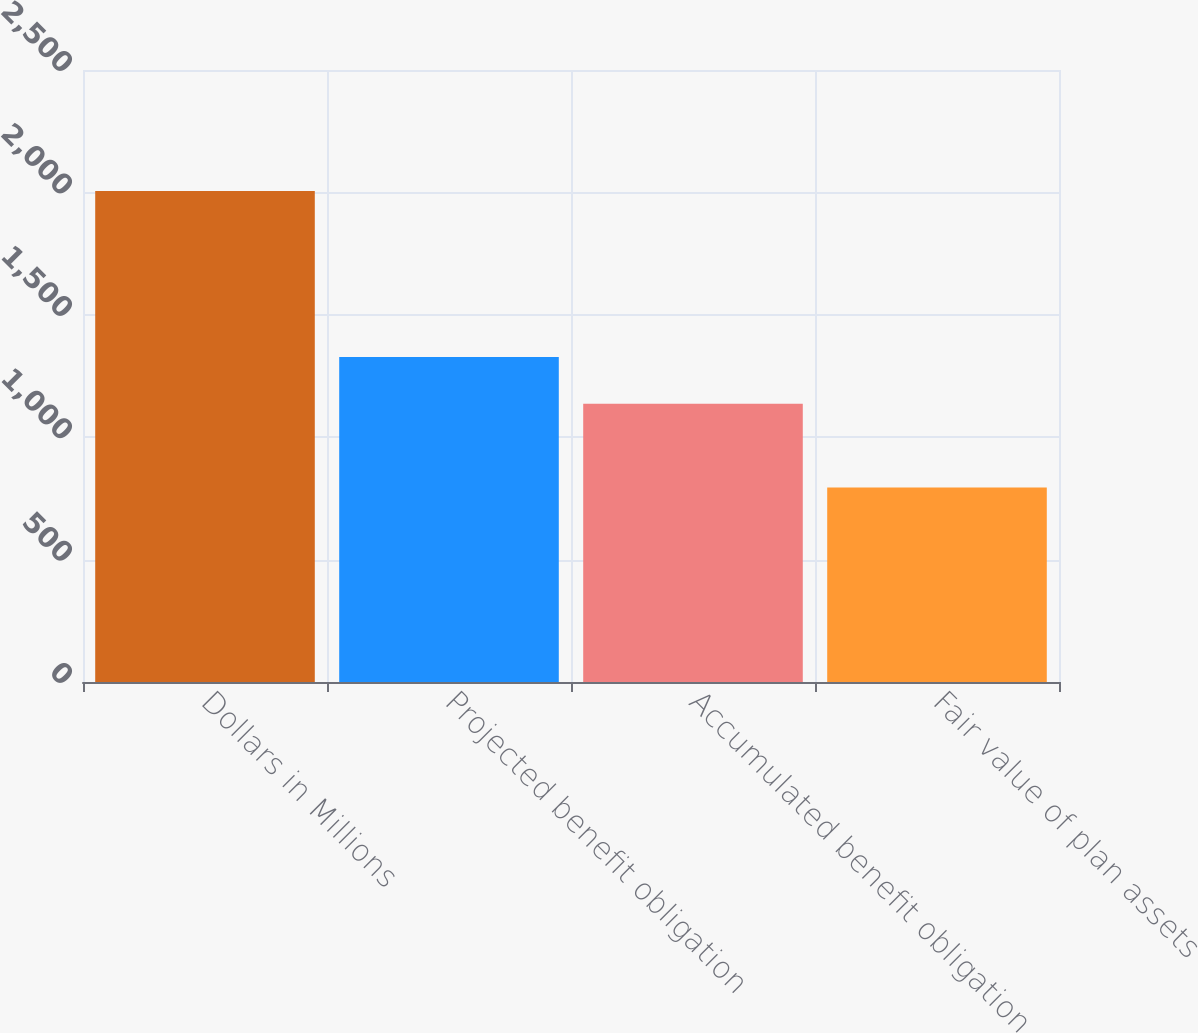Convert chart to OTSL. <chart><loc_0><loc_0><loc_500><loc_500><bar_chart><fcel>Dollars in Millions<fcel>Projected benefit obligation<fcel>Accumulated benefit obligation<fcel>Fair value of plan assets<nl><fcel>2006<fcel>1328<fcel>1137<fcel>795<nl></chart> 